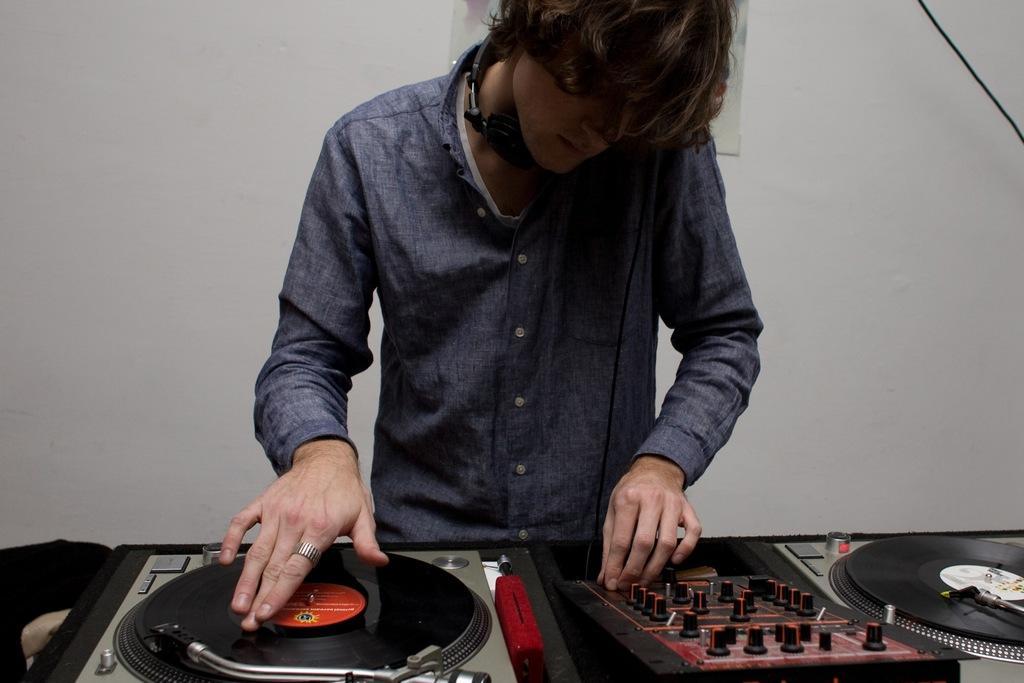Could you give a brief overview of what you see in this image? In this picture, we see a man is playing the disc jockey which is placed on the table. In front of him, we see a table on which the amplifier and the disc jockey are placed. I think he is wearing the headset. In the background, we see a white wall on which the photo frame is placed. 